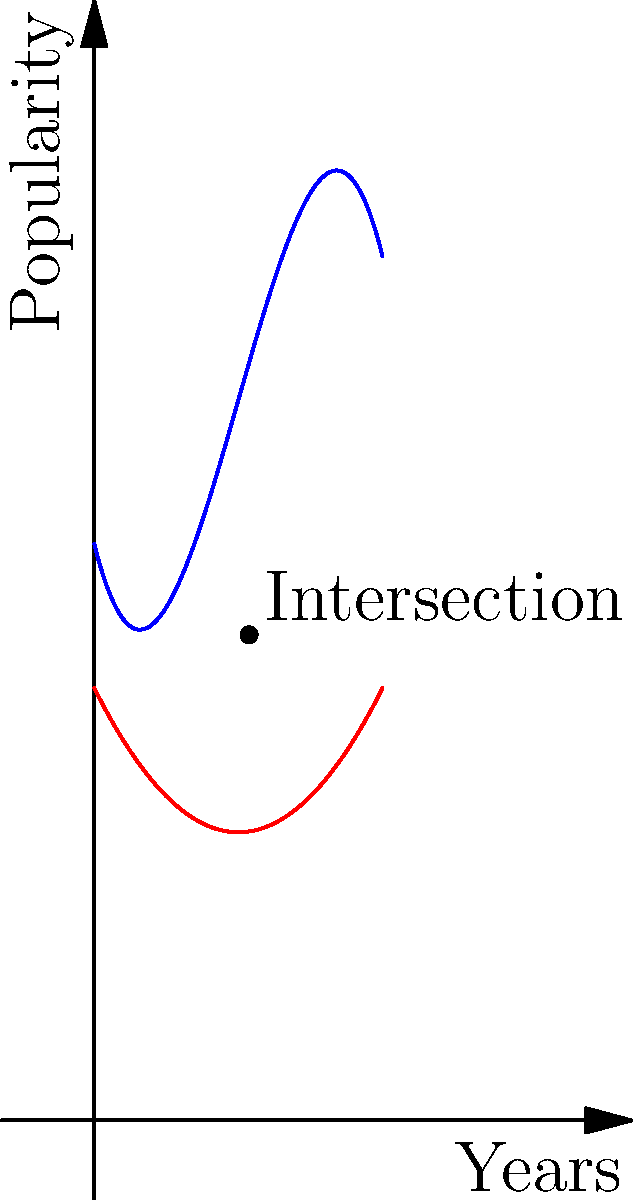In our comedy club days, we saw different styles rise and fall in popularity. The graph shows the popularity trends of stand-up (blue) and sketch comedy (red) over a 10-year period. The $y$-axis represents popularity on a scale of 0-30, and the $x$-axis represents years. The stand-up trend is modeled by $f(x) = -0.1x^3 + 1.5x^2 - 4x + 20$, while the sketch comedy trend is modeled by $g(x) = 0.2x^2 - 2x + 15$. At what year (to the nearest tenth) do these two comedy styles have equal popularity? To find when the two comedy styles have equal popularity, we need to find the intersection point of the two curves. This means solving the equation:

$$-0.1x^3 + 1.5x^2 - 4x + 20 = 0.2x^2 - 2x + 15$$

Rearranging the equation:

$$-0.1x^3 + 1.3x^2 - 2x + 5 = 0$$

This is a cubic equation that's difficult to solve by hand. Using a graphing calculator or computer algebra system, we can find that this equation has one real solution at approximately $x = 5.37$.

To verify, we can plug this value back into both original functions:

$f(5.37) \approx 16.85$
$g(5.37) \approx 16.85$

This confirms that the two styles have equal popularity at about 5.37 years.

Rounding to the nearest tenth, our answer is 5.4 years.
Answer: 5.4 years 